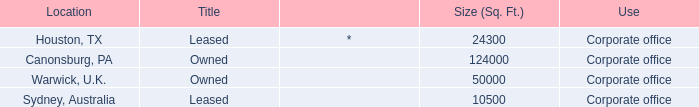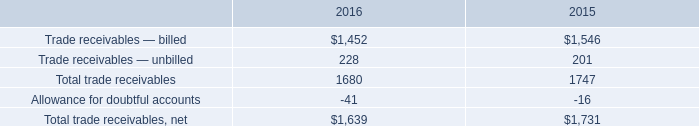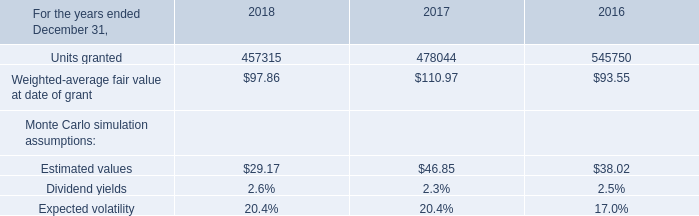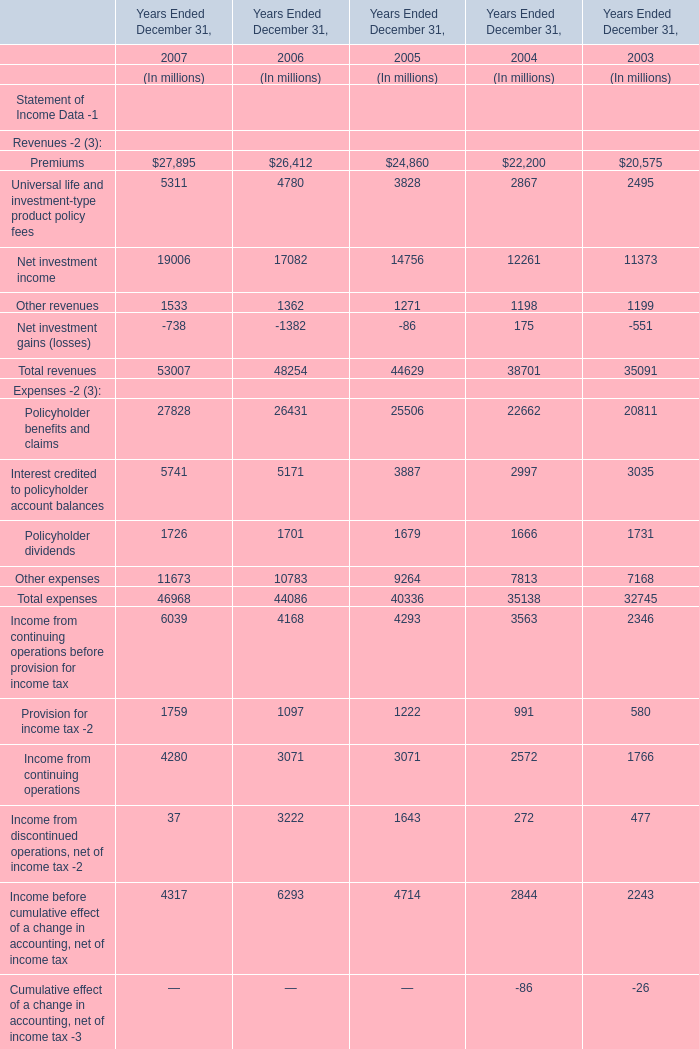what is the percentage change in total trade net receivables? 
Computations: ((1639 - 1731) / 1731)
Answer: -0.05315. 